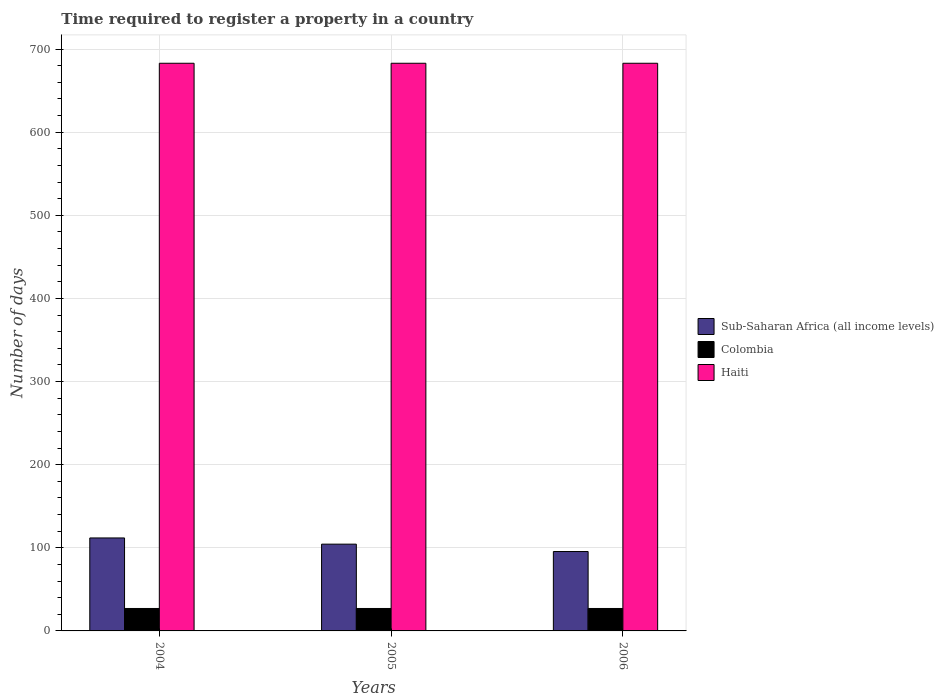How many groups of bars are there?
Offer a very short reply. 3. Are the number of bars per tick equal to the number of legend labels?
Offer a very short reply. Yes. Are the number of bars on each tick of the X-axis equal?
Provide a short and direct response. Yes. What is the label of the 3rd group of bars from the left?
Provide a short and direct response. 2006. What is the number of days required to register a property in Sub-Saharan Africa (all income levels) in 2004?
Make the answer very short. 111.86. Across all years, what is the maximum number of days required to register a property in Colombia?
Give a very brief answer. 27. Across all years, what is the minimum number of days required to register a property in Colombia?
Your answer should be very brief. 27. In which year was the number of days required to register a property in Haiti maximum?
Ensure brevity in your answer.  2004. In which year was the number of days required to register a property in Colombia minimum?
Give a very brief answer. 2004. What is the total number of days required to register a property in Haiti in the graph?
Your response must be concise. 2049. What is the difference between the number of days required to register a property in Sub-Saharan Africa (all income levels) in 2005 and that in 2006?
Keep it short and to the point. 8.88. What is the difference between the number of days required to register a property in Sub-Saharan Africa (all income levels) in 2005 and the number of days required to register a property in Colombia in 2006?
Your answer should be very brief. 77.41. What is the average number of days required to register a property in Colombia per year?
Keep it short and to the point. 27. In the year 2006, what is the difference between the number of days required to register a property in Sub-Saharan Africa (all income levels) and number of days required to register a property in Colombia?
Make the answer very short. 68.53. What is the ratio of the number of days required to register a property in Sub-Saharan Africa (all income levels) in 2005 to that in 2006?
Make the answer very short. 1.09. What is the difference between the highest and the second highest number of days required to register a property in Sub-Saharan Africa (all income levels)?
Ensure brevity in your answer.  7.45. In how many years, is the number of days required to register a property in Colombia greater than the average number of days required to register a property in Colombia taken over all years?
Ensure brevity in your answer.  0. Is the sum of the number of days required to register a property in Colombia in 2005 and 2006 greater than the maximum number of days required to register a property in Sub-Saharan Africa (all income levels) across all years?
Provide a short and direct response. No. What does the 1st bar from the left in 2004 represents?
Keep it short and to the point. Sub-Saharan Africa (all income levels). What does the 2nd bar from the right in 2006 represents?
Ensure brevity in your answer.  Colombia. Is it the case that in every year, the sum of the number of days required to register a property in Haiti and number of days required to register a property in Colombia is greater than the number of days required to register a property in Sub-Saharan Africa (all income levels)?
Your answer should be very brief. Yes. How many years are there in the graph?
Provide a short and direct response. 3. Does the graph contain grids?
Your response must be concise. Yes. How are the legend labels stacked?
Your answer should be very brief. Vertical. What is the title of the graph?
Give a very brief answer. Time required to register a property in a country. Does "Venezuela" appear as one of the legend labels in the graph?
Make the answer very short. No. What is the label or title of the X-axis?
Your answer should be very brief. Years. What is the label or title of the Y-axis?
Your answer should be very brief. Number of days. What is the Number of days in Sub-Saharan Africa (all income levels) in 2004?
Keep it short and to the point. 111.86. What is the Number of days in Haiti in 2004?
Offer a terse response. 683. What is the Number of days in Sub-Saharan Africa (all income levels) in 2005?
Your answer should be compact. 104.41. What is the Number of days in Haiti in 2005?
Your answer should be compact. 683. What is the Number of days in Sub-Saharan Africa (all income levels) in 2006?
Make the answer very short. 95.53. What is the Number of days in Colombia in 2006?
Offer a terse response. 27. What is the Number of days of Haiti in 2006?
Offer a very short reply. 683. Across all years, what is the maximum Number of days in Sub-Saharan Africa (all income levels)?
Ensure brevity in your answer.  111.86. Across all years, what is the maximum Number of days of Haiti?
Ensure brevity in your answer.  683. Across all years, what is the minimum Number of days of Sub-Saharan Africa (all income levels)?
Provide a short and direct response. 95.53. Across all years, what is the minimum Number of days of Haiti?
Ensure brevity in your answer.  683. What is the total Number of days in Sub-Saharan Africa (all income levels) in the graph?
Your response must be concise. 311.8. What is the total Number of days in Haiti in the graph?
Your response must be concise. 2049. What is the difference between the Number of days of Sub-Saharan Africa (all income levels) in 2004 and that in 2005?
Ensure brevity in your answer.  7.45. What is the difference between the Number of days in Colombia in 2004 and that in 2005?
Your response must be concise. 0. What is the difference between the Number of days of Sub-Saharan Africa (all income levels) in 2004 and that in 2006?
Provide a short and direct response. 16.33. What is the difference between the Number of days in Haiti in 2004 and that in 2006?
Make the answer very short. 0. What is the difference between the Number of days in Sub-Saharan Africa (all income levels) in 2005 and that in 2006?
Offer a terse response. 8.88. What is the difference between the Number of days in Haiti in 2005 and that in 2006?
Provide a succinct answer. 0. What is the difference between the Number of days in Sub-Saharan Africa (all income levels) in 2004 and the Number of days in Colombia in 2005?
Offer a terse response. 84.86. What is the difference between the Number of days of Sub-Saharan Africa (all income levels) in 2004 and the Number of days of Haiti in 2005?
Offer a terse response. -571.14. What is the difference between the Number of days in Colombia in 2004 and the Number of days in Haiti in 2005?
Give a very brief answer. -656. What is the difference between the Number of days in Sub-Saharan Africa (all income levels) in 2004 and the Number of days in Colombia in 2006?
Offer a terse response. 84.86. What is the difference between the Number of days in Sub-Saharan Africa (all income levels) in 2004 and the Number of days in Haiti in 2006?
Offer a terse response. -571.14. What is the difference between the Number of days in Colombia in 2004 and the Number of days in Haiti in 2006?
Your response must be concise. -656. What is the difference between the Number of days of Sub-Saharan Africa (all income levels) in 2005 and the Number of days of Colombia in 2006?
Ensure brevity in your answer.  77.41. What is the difference between the Number of days of Sub-Saharan Africa (all income levels) in 2005 and the Number of days of Haiti in 2006?
Your answer should be very brief. -578.59. What is the difference between the Number of days in Colombia in 2005 and the Number of days in Haiti in 2006?
Offer a very short reply. -656. What is the average Number of days in Sub-Saharan Africa (all income levels) per year?
Offer a very short reply. 103.93. What is the average Number of days in Colombia per year?
Give a very brief answer. 27. What is the average Number of days of Haiti per year?
Your response must be concise. 683. In the year 2004, what is the difference between the Number of days in Sub-Saharan Africa (all income levels) and Number of days in Colombia?
Offer a terse response. 84.86. In the year 2004, what is the difference between the Number of days of Sub-Saharan Africa (all income levels) and Number of days of Haiti?
Your answer should be compact. -571.14. In the year 2004, what is the difference between the Number of days in Colombia and Number of days in Haiti?
Make the answer very short. -656. In the year 2005, what is the difference between the Number of days in Sub-Saharan Africa (all income levels) and Number of days in Colombia?
Keep it short and to the point. 77.41. In the year 2005, what is the difference between the Number of days in Sub-Saharan Africa (all income levels) and Number of days in Haiti?
Make the answer very short. -578.59. In the year 2005, what is the difference between the Number of days of Colombia and Number of days of Haiti?
Give a very brief answer. -656. In the year 2006, what is the difference between the Number of days in Sub-Saharan Africa (all income levels) and Number of days in Colombia?
Provide a short and direct response. 68.53. In the year 2006, what is the difference between the Number of days of Sub-Saharan Africa (all income levels) and Number of days of Haiti?
Keep it short and to the point. -587.47. In the year 2006, what is the difference between the Number of days in Colombia and Number of days in Haiti?
Your response must be concise. -656. What is the ratio of the Number of days of Sub-Saharan Africa (all income levels) in 2004 to that in 2005?
Provide a short and direct response. 1.07. What is the ratio of the Number of days of Sub-Saharan Africa (all income levels) in 2004 to that in 2006?
Give a very brief answer. 1.17. What is the ratio of the Number of days of Sub-Saharan Africa (all income levels) in 2005 to that in 2006?
Make the answer very short. 1.09. What is the ratio of the Number of days of Haiti in 2005 to that in 2006?
Your answer should be very brief. 1. What is the difference between the highest and the second highest Number of days in Sub-Saharan Africa (all income levels)?
Keep it short and to the point. 7.45. What is the difference between the highest and the lowest Number of days of Sub-Saharan Africa (all income levels)?
Provide a short and direct response. 16.33. 